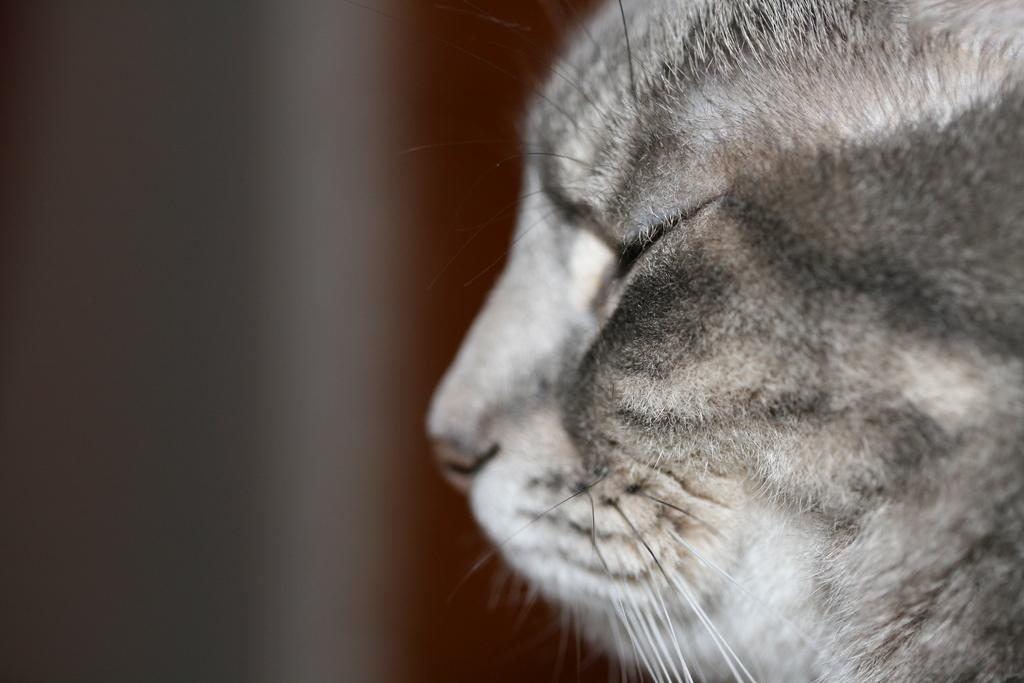What is the focus of the image? The image is zoomed in, so the focus is on a specific detail. What can be seen in the center of the image? There is an animal's face visible in the image. What is the appearance of the background in the image? The background of the image is blurred. What type of hair can be seen on the animal's face in the image? There is no hair visible on the animal's face in the image, as the image is focused on the face itself and not on any specific details of the fur or hair. 